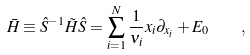<formula> <loc_0><loc_0><loc_500><loc_500>\bar { H } \equiv \hat { S } ^ { - 1 } \tilde { H } \hat { S } = \sum _ { i = 1 } ^ { N } \frac { 1 } { \nu _ { i } } x _ { i } \partial _ { x _ { i } } + E _ { 0 } \quad ,</formula> 